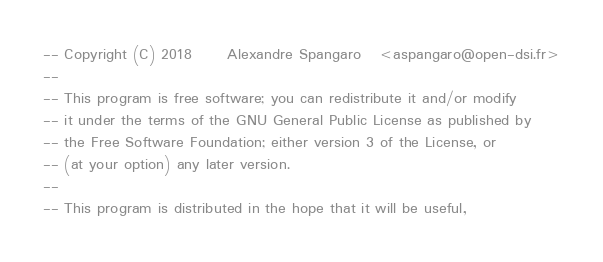<code> <loc_0><loc_0><loc_500><loc_500><_SQL_>-- Copyright (C) 2018      Alexandre Spangaro   <aspangaro@open-dsi.fr>
--
-- This program is free software; you can redistribute it and/or modify
-- it under the terms of the GNU General Public License as published by
-- the Free Software Foundation; either version 3 of the License, or
-- (at your option) any later version.
--
-- This program is distributed in the hope that it will be useful,</code> 